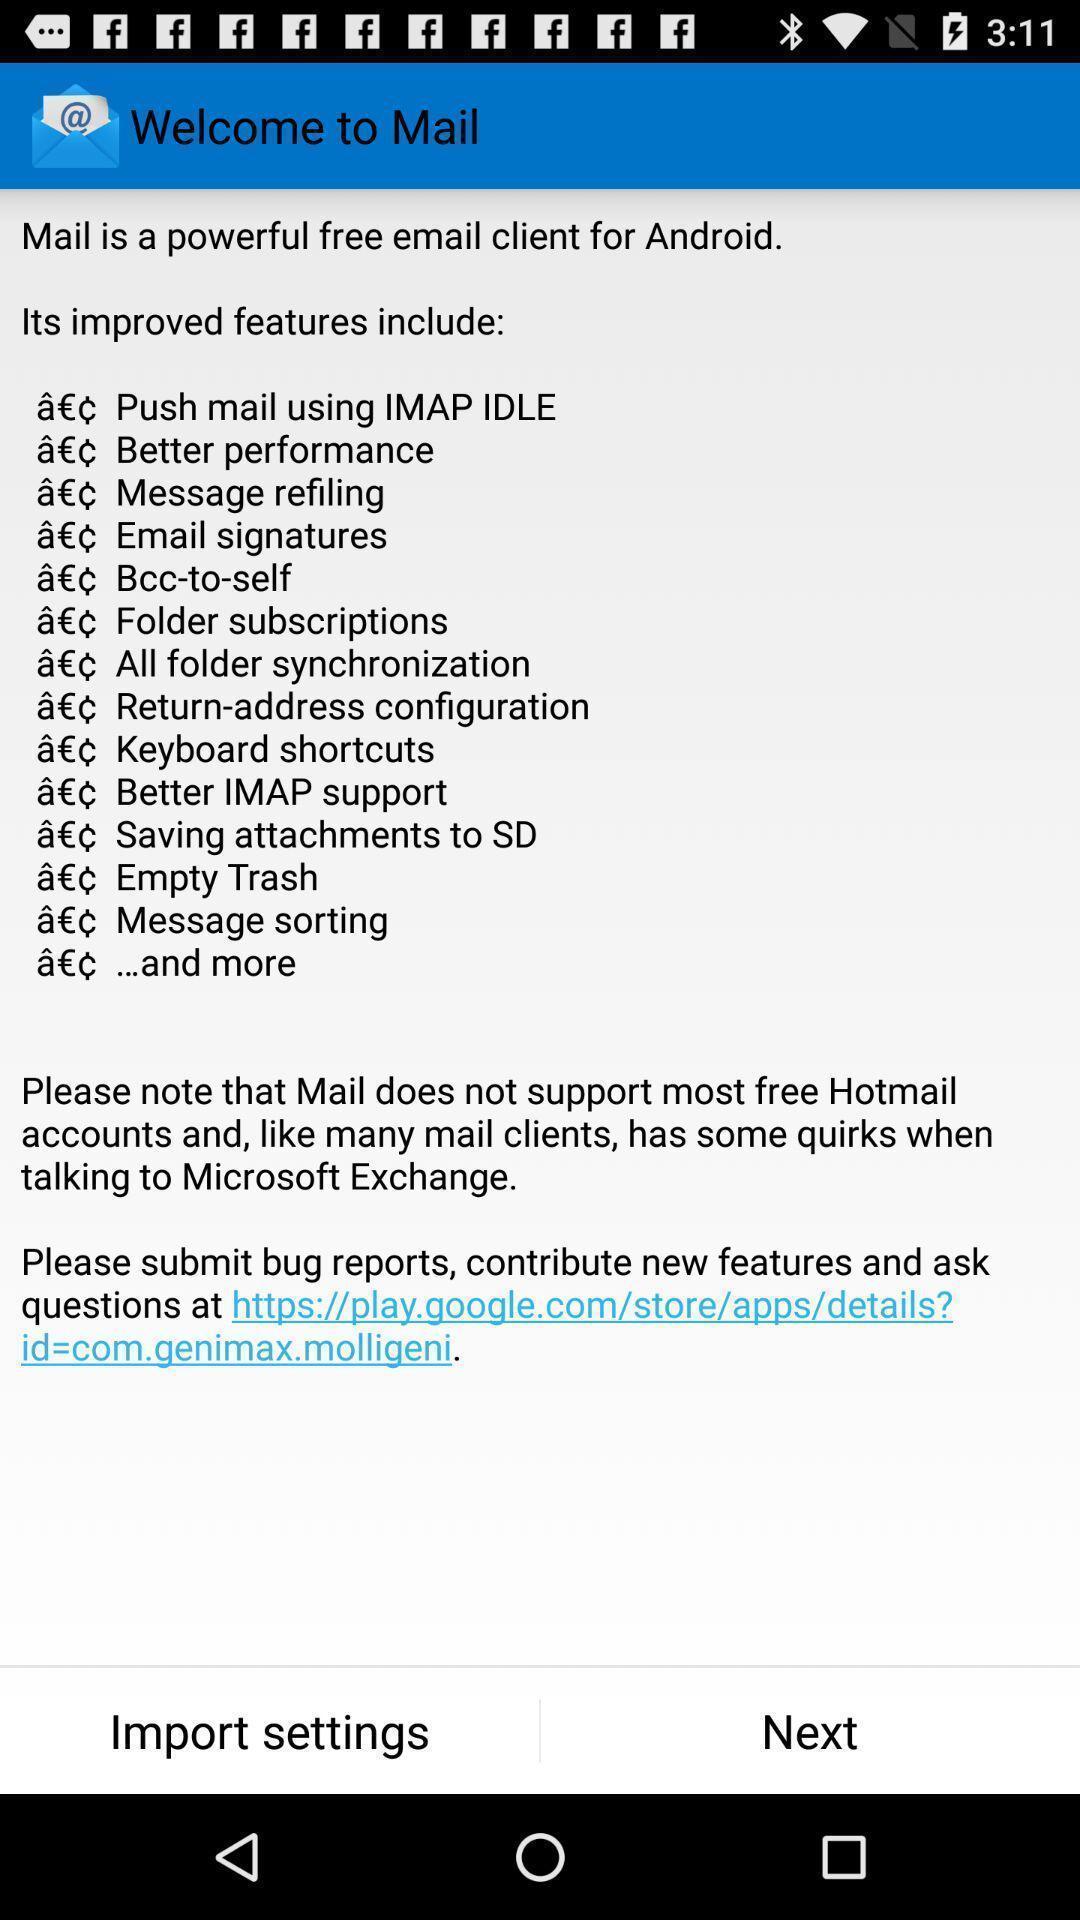Describe the content in this image. Welcome page with features include displayed. 